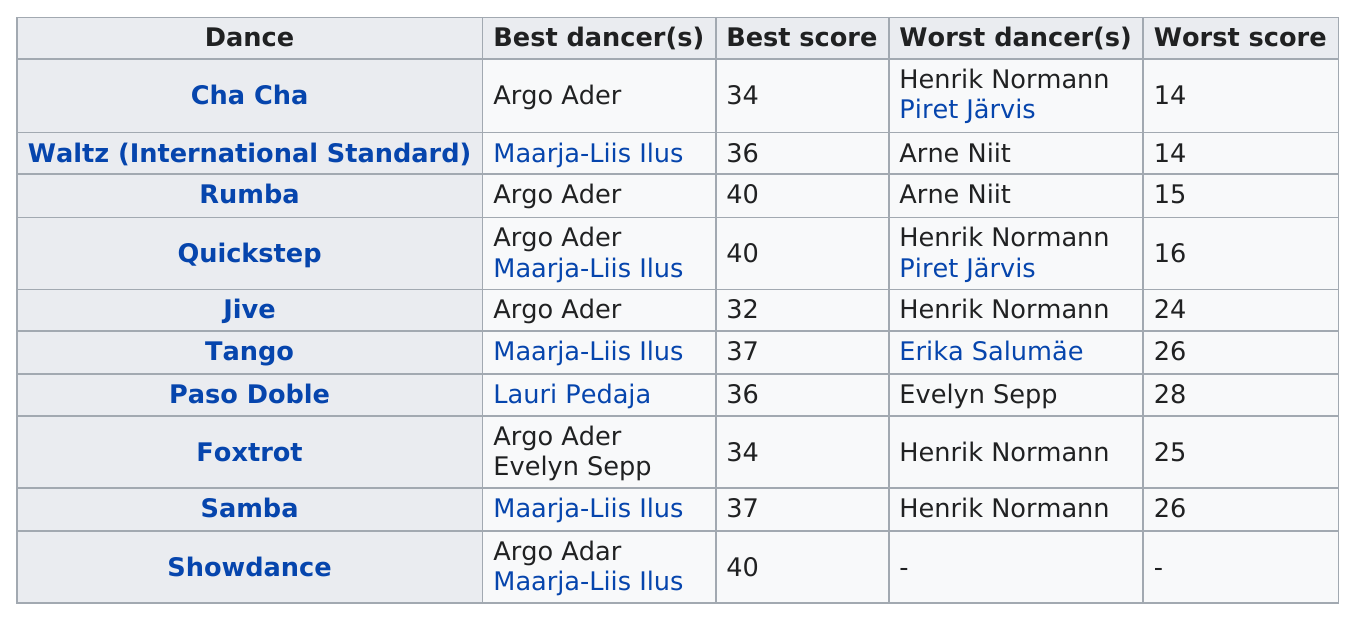Indicate a few pertinent items in this graphic. The largest score listed is 40. The dance that precedes tango is jive. Argo Ader scored higher than Lauri Pedaja in the quickstep and paso doble competitions. Argo was the best dancer for a total of 6 consecutive times. The total of the best scores listed is 366. 